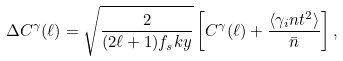Convert formula to latex. <formula><loc_0><loc_0><loc_500><loc_500>\Delta C ^ { \gamma } ( \ell ) = \sqrt { \frac { 2 } { ( 2 \ell + 1 ) f _ { s } k y } } \left [ C ^ { \gamma } ( \ell ) + \frac { \langle { \gamma _ { i } n t } ^ { 2 } \rangle } { \bar { n } } \right ] ,</formula> 